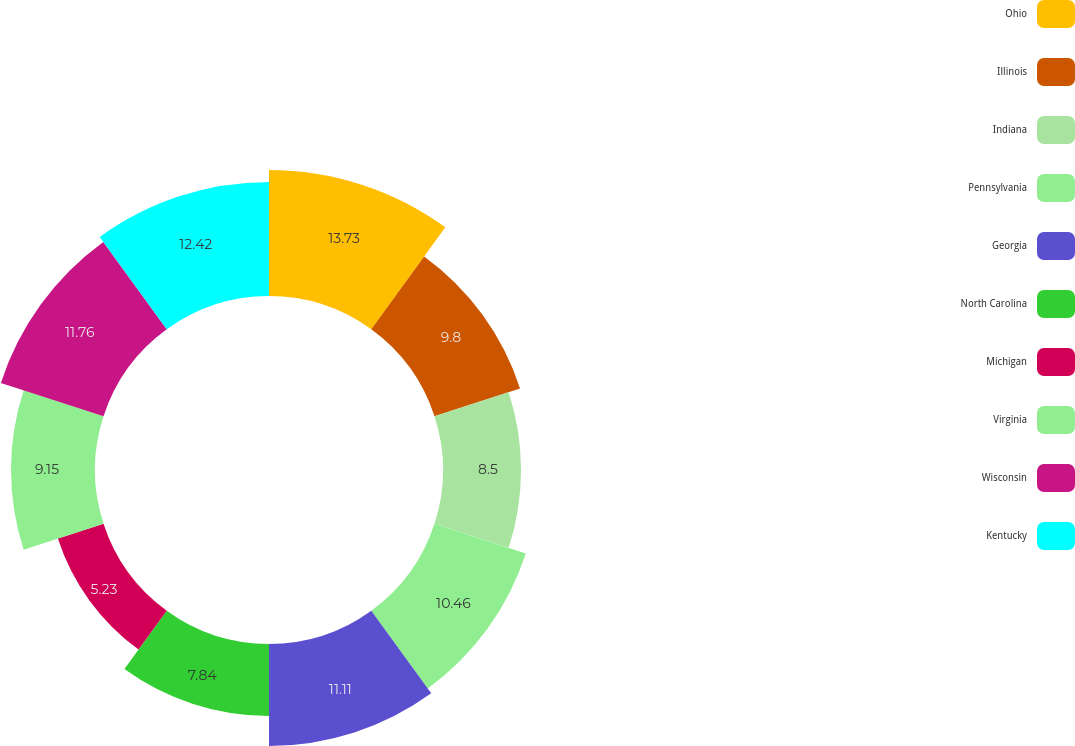<chart> <loc_0><loc_0><loc_500><loc_500><pie_chart><fcel>Ohio<fcel>Illinois<fcel>Indiana<fcel>Pennsylvania<fcel>Georgia<fcel>North Carolina<fcel>Michigan<fcel>Virginia<fcel>Wisconsin<fcel>Kentucky<nl><fcel>13.73%<fcel>9.8%<fcel>8.5%<fcel>10.46%<fcel>11.11%<fcel>7.84%<fcel>5.23%<fcel>9.15%<fcel>11.76%<fcel>12.42%<nl></chart> 